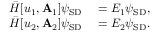<formula> <loc_0><loc_0><loc_500><loc_500>\begin{array} { r l } { \bar { H } [ u _ { 1 } , A _ { 1 } ] \psi _ { S D } } & = E _ { 1 } \psi _ { S D } , } \\ { \bar { H } [ u _ { 2 } , A _ { 2 } ] \psi _ { S D } } & = E _ { 2 } \psi _ { S D } . } \end{array}</formula> 